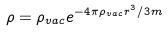<formula> <loc_0><loc_0><loc_500><loc_500>\rho = \rho _ { v a c } e ^ { - 4 \pi \rho _ { v a c } r ^ { 3 } / 3 m }</formula> 